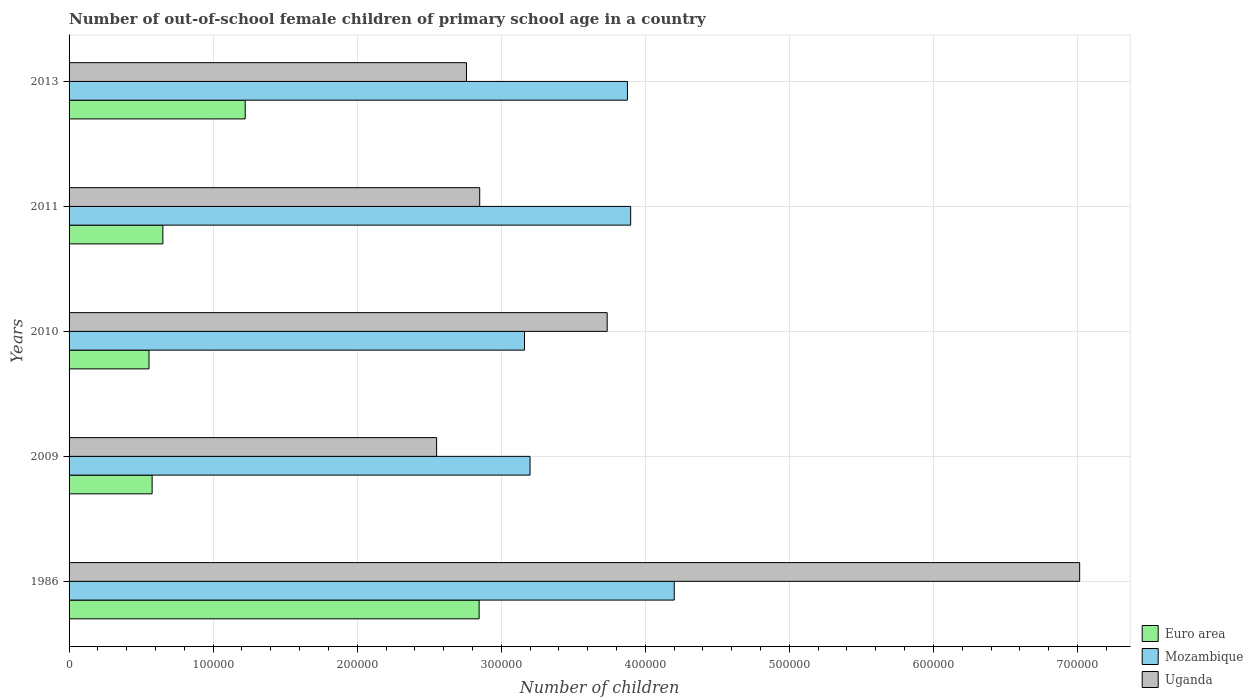How many different coloured bars are there?
Provide a succinct answer. 3. How many groups of bars are there?
Your response must be concise. 5. Are the number of bars per tick equal to the number of legend labels?
Keep it short and to the point. Yes. How many bars are there on the 5th tick from the top?
Your answer should be compact. 3. What is the label of the 3rd group of bars from the top?
Keep it short and to the point. 2010. What is the number of out-of-school female children in Uganda in 2013?
Keep it short and to the point. 2.76e+05. Across all years, what is the maximum number of out-of-school female children in Mozambique?
Your answer should be compact. 4.20e+05. Across all years, what is the minimum number of out-of-school female children in Euro area?
Your answer should be compact. 5.55e+04. In which year was the number of out-of-school female children in Uganda minimum?
Give a very brief answer. 2009. What is the total number of out-of-school female children in Euro area in the graph?
Give a very brief answer. 5.85e+05. What is the difference between the number of out-of-school female children in Mozambique in 2009 and that in 2011?
Provide a short and direct response. -6.98e+04. What is the difference between the number of out-of-school female children in Uganda in 2009 and the number of out-of-school female children in Euro area in 2011?
Give a very brief answer. 1.90e+05. What is the average number of out-of-school female children in Mozambique per year?
Your answer should be compact. 3.67e+05. In the year 2009, what is the difference between the number of out-of-school female children in Euro area and number of out-of-school female children in Mozambique?
Ensure brevity in your answer.  -2.62e+05. In how many years, is the number of out-of-school female children in Euro area greater than 340000 ?
Your response must be concise. 0. What is the ratio of the number of out-of-school female children in Euro area in 2009 to that in 2011?
Provide a succinct answer. 0.89. What is the difference between the highest and the second highest number of out-of-school female children in Mozambique?
Provide a succinct answer. 3.02e+04. What is the difference between the highest and the lowest number of out-of-school female children in Mozambique?
Your answer should be very brief. 1.04e+05. Is the sum of the number of out-of-school female children in Uganda in 1986 and 2013 greater than the maximum number of out-of-school female children in Mozambique across all years?
Provide a succinct answer. Yes. Are all the bars in the graph horizontal?
Provide a succinct answer. Yes. How many years are there in the graph?
Provide a short and direct response. 5. Are the values on the major ticks of X-axis written in scientific E-notation?
Your answer should be compact. No. Does the graph contain grids?
Provide a succinct answer. Yes. How many legend labels are there?
Your answer should be very brief. 3. What is the title of the graph?
Your answer should be very brief. Number of out-of-school female children of primary school age in a country. Does "Morocco" appear as one of the legend labels in the graph?
Ensure brevity in your answer.  No. What is the label or title of the X-axis?
Offer a very short reply. Number of children. What is the label or title of the Y-axis?
Make the answer very short. Years. What is the Number of children of Euro area in 1986?
Make the answer very short. 2.85e+05. What is the Number of children of Mozambique in 1986?
Your answer should be compact. 4.20e+05. What is the Number of children of Uganda in 1986?
Offer a terse response. 7.02e+05. What is the Number of children of Euro area in 2009?
Make the answer very short. 5.77e+04. What is the Number of children of Mozambique in 2009?
Ensure brevity in your answer.  3.20e+05. What is the Number of children of Uganda in 2009?
Provide a short and direct response. 2.55e+05. What is the Number of children in Euro area in 2010?
Provide a succinct answer. 5.55e+04. What is the Number of children of Mozambique in 2010?
Provide a short and direct response. 3.16e+05. What is the Number of children in Uganda in 2010?
Provide a succinct answer. 3.74e+05. What is the Number of children of Euro area in 2011?
Provide a short and direct response. 6.51e+04. What is the Number of children of Mozambique in 2011?
Offer a terse response. 3.90e+05. What is the Number of children in Uganda in 2011?
Keep it short and to the point. 2.85e+05. What is the Number of children of Euro area in 2013?
Your answer should be compact. 1.22e+05. What is the Number of children in Mozambique in 2013?
Provide a succinct answer. 3.88e+05. What is the Number of children in Uganda in 2013?
Ensure brevity in your answer.  2.76e+05. Across all years, what is the maximum Number of children of Euro area?
Keep it short and to the point. 2.85e+05. Across all years, what is the maximum Number of children of Mozambique?
Keep it short and to the point. 4.20e+05. Across all years, what is the maximum Number of children of Uganda?
Your answer should be very brief. 7.02e+05. Across all years, what is the minimum Number of children in Euro area?
Offer a terse response. 5.55e+04. Across all years, what is the minimum Number of children in Mozambique?
Ensure brevity in your answer.  3.16e+05. Across all years, what is the minimum Number of children in Uganda?
Give a very brief answer. 2.55e+05. What is the total Number of children of Euro area in the graph?
Your answer should be very brief. 5.85e+05. What is the total Number of children in Mozambique in the graph?
Your answer should be compact. 1.83e+06. What is the total Number of children of Uganda in the graph?
Keep it short and to the point. 1.89e+06. What is the difference between the Number of children in Euro area in 1986 and that in 2009?
Offer a very short reply. 2.27e+05. What is the difference between the Number of children of Mozambique in 1986 and that in 2009?
Provide a succinct answer. 1.00e+05. What is the difference between the Number of children of Uganda in 1986 and that in 2009?
Offer a very short reply. 4.46e+05. What is the difference between the Number of children of Euro area in 1986 and that in 2010?
Your answer should be compact. 2.29e+05. What is the difference between the Number of children in Mozambique in 1986 and that in 2010?
Provide a succinct answer. 1.04e+05. What is the difference between the Number of children in Uganda in 1986 and that in 2010?
Give a very brief answer. 3.28e+05. What is the difference between the Number of children in Euro area in 1986 and that in 2011?
Offer a terse response. 2.20e+05. What is the difference between the Number of children in Mozambique in 1986 and that in 2011?
Offer a very short reply. 3.02e+04. What is the difference between the Number of children of Uganda in 1986 and that in 2011?
Offer a very short reply. 4.16e+05. What is the difference between the Number of children in Euro area in 1986 and that in 2013?
Offer a terse response. 1.62e+05. What is the difference between the Number of children in Mozambique in 1986 and that in 2013?
Your answer should be compact. 3.25e+04. What is the difference between the Number of children of Uganda in 1986 and that in 2013?
Make the answer very short. 4.26e+05. What is the difference between the Number of children in Euro area in 2009 and that in 2010?
Offer a very short reply. 2158. What is the difference between the Number of children of Mozambique in 2009 and that in 2010?
Your answer should be compact. 3842. What is the difference between the Number of children in Uganda in 2009 and that in 2010?
Keep it short and to the point. -1.18e+05. What is the difference between the Number of children of Euro area in 2009 and that in 2011?
Your response must be concise. -7461. What is the difference between the Number of children of Mozambique in 2009 and that in 2011?
Your answer should be compact. -6.98e+04. What is the difference between the Number of children of Uganda in 2009 and that in 2011?
Your answer should be compact. -2.99e+04. What is the difference between the Number of children of Euro area in 2009 and that in 2013?
Ensure brevity in your answer.  -6.46e+04. What is the difference between the Number of children of Mozambique in 2009 and that in 2013?
Offer a very short reply. -6.76e+04. What is the difference between the Number of children in Uganda in 2009 and that in 2013?
Give a very brief answer. -2.07e+04. What is the difference between the Number of children in Euro area in 2010 and that in 2011?
Keep it short and to the point. -9619. What is the difference between the Number of children of Mozambique in 2010 and that in 2011?
Ensure brevity in your answer.  -7.37e+04. What is the difference between the Number of children of Uganda in 2010 and that in 2011?
Offer a terse response. 8.85e+04. What is the difference between the Number of children of Euro area in 2010 and that in 2013?
Provide a succinct answer. -6.68e+04. What is the difference between the Number of children of Mozambique in 2010 and that in 2013?
Ensure brevity in your answer.  -7.14e+04. What is the difference between the Number of children in Uganda in 2010 and that in 2013?
Provide a succinct answer. 9.77e+04. What is the difference between the Number of children in Euro area in 2011 and that in 2013?
Provide a short and direct response. -5.72e+04. What is the difference between the Number of children of Mozambique in 2011 and that in 2013?
Make the answer very short. 2252. What is the difference between the Number of children of Uganda in 2011 and that in 2013?
Your answer should be compact. 9186. What is the difference between the Number of children in Euro area in 1986 and the Number of children in Mozambique in 2009?
Provide a short and direct response. -3.53e+04. What is the difference between the Number of children in Euro area in 1986 and the Number of children in Uganda in 2009?
Your response must be concise. 2.95e+04. What is the difference between the Number of children of Mozambique in 1986 and the Number of children of Uganda in 2009?
Your response must be concise. 1.65e+05. What is the difference between the Number of children in Euro area in 1986 and the Number of children in Mozambique in 2010?
Make the answer very short. -3.15e+04. What is the difference between the Number of children of Euro area in 1986 and the Number of children of Uganda in 2010?
Offer a terse response. -8.89e+04. What is the difference between the Number of children in Mozambique in 1986 and the Number of children in Uganda in 2010?
Your response must be concise. 4.65e+04. What is the difference between the Number of children in Euro area in 1986 and the Number of children in Mozambique in 2011?
Offer a terse response. -1.05e+05. What is the difference between the Number of children in Euro area in 1986 and the Number of children in Uganda in 2011?
Provide a short and direct response. -399. What is the difference between the Number of children in Mozambique in 1986 and the Number of children in Uganda in 2011?
Offer a terse response. 1.35e+05. What is the difference between the Number of children of Euro area in 1986 and the Number of children of Mozambique in 2013?
Make the answer very short. -1.03e+05. What is the difference between the Number of children of Euro area in 1986 and the Number of children of Uganda in 2013?
Your response must be concise. 8787. What is the difference between the Number of children in Mozambique in 1986 and the Number of children in Uganda in 2013?
Provide a succinct answer. 1.44e+05. What is the difference between the Number of children of Euro area in 2009 and the Number of children of Mozambique in 2010?
Make the answer very short. -2.59e+05. What is the difference between the Number of children in Euro area in 2009 and the Number of children in Uganda in 2010?
Your answer should be very brief. -3.16e+05. What is the difference between the Number of children of Mozambique in 2009 and the Number of children of Uganda in 2010?
Provide a short and direct response. -5.36e+04. What is the difference between the Number of children in Euro area in 2009 and the Number of children in Mozambique in 2011?
Your answer should be compact. -3.32e+05. What is the difference between the Number of children of Euro area in 2009 and the Number of children of Uganda in 2011?
Ensure brevity in your answer.  -2.27e+05. What is the difference between the Number of children of Mozambique in 2009 and the Number of children of Uganda in 2011?
Your answer should be compact. 3.49e+04. What is the difference between the Number of children of Euro area in 2009 and the Number of children of Mozambique in 2013?
Offer a very short reply. -3.30e+05. What is the difference between the Number of children in Euro area in 2009 and the Number of children in Uganda in 2013?
Make the answer very short. -2.18e+05. What is the difference between the Number of children of Mozambique in 2009 and the Number of children of Uganda in 2013?
Your answer should be very brief. 4.41e+04. What is the difference between the Number of children of Euro area in 2010 and the Number of children of Mozambique in 2011?
Offer a terse response. -3.34e+05. What is the difference between the Number of children of Euro area in 2010 and the Number of children of Uganda in 2011?
Make the answer very short. -2.30e+05. What is the difference between the Number of children of Mozambique in 2010 and the Number of children of Uganda in 2011?
Your answer should be compact. 3.11e+04. What is the difference between the Number of children in Euro area in 2010 and the Number of children in Mozambique in 2013?
Offer a very short reply. -3.32e+05. What is the difference between the Number of children of Euro area in 2010 and the Number of children of Uganda in 2013?
Provide a short and direct response. -2.20e+05. What is the difference between the Number of children in Mozambique in 2010 and the Number of children in Uganda in 2013?
Provide a short and direct response. 4.03e+04. What is the difference between the Number of children in Euro area in 2011 and the Number of children in Mozambique in 2013?
Ensure brevity in your answer.  -3.22e+05. What is the difference between the Number of children of Euro area in 2011 and the Number of children of Uganda in 2013?
Your answer should be compact. -2.11e+05. What is the difference between the Number of children of Mozambique in 2011 and the Number of children of Uganda in 2013?
Offer a terse response. 1.14e+05. What is the average Number of children of Euro area per year?
Ensure brevity in your answer.  1.17e+05. What is the average Number of children of Mozambique per year?
Provide a succinct answer. 3.67e+05. What is the average Number of children of Uganda per year?
Provide a succinct answer. 3.78e+05. In the year 1986, what is the difference between the Number of children of Euro area and Number of children of Mozambique?
Ensure brevity in your answer.  -1.35e+05. In the year 1986, what is the difference between the Number of children of Euro area and Number of children of Uganda?
Offer a terse response. -4.17e+05. In the year 1986, what is the difference between the Number of children in Mozambique and Number of children in Uganda?
Provide a short and direct response. -2.81e+05. In the year 2009, what is the difference between the Number of children of Euro area and Number of children of Mozambique?
Ensure brevity in your answer.  -2.62e+05. In the year 2009, what is the difference between the Number of children of Euro area and Number of children of Uganda?
Offer a terse response. -1.97e+05. In the year 2009, what is the difference between the Number of children of Mozambique and Number of children of Uganda?
Give a very brief answer. 6.49e+04. In the year 2010, what is the difference between the Number of children in Euro area and Number of children in Mozambique?
Provide a short and direct response. -2.61e+05. In the year 2010, what is the difference between the Number of children of Euro area and Number of children of Uganda?
Your response must be concise. -3.18e+05. In the year 2010, what is the difference between the Number of children of Mozambique and Number of children of Uganda?
Offer a very short reply. -5.74e+04. In the year 2011, what is the difference between the Number of children in Euro area and Number of children in Mozambique?
Ensure brevity in your answer.  -3.25e+05. In the year 2011, what is the difference between the Number of children in Euro area and Number of children in Uganda?
Keep it short and to the point. -2.20e+05. In the year 2011, what is the difference between the Number of children in Mozambique and Number of children in Uganda?
Your answer should be compact. 1.05e+05. In the year 2013, what is the difference between the Number of children of Euro area and Number of children of Mozambique?
Your answer should be very brief. -2.65e+05. In the year 2013, what is the difference between the Number of children of Euro area and Number of children of Uganda?
Offer a terse response. -1.54e+05. In the year 2013, what is the difference between the Number of children of Mozambique and Number of children of Uganda?
Provide a short and direct response. 1.12e+05. What is the ratio of the Number of children in Euro area in 1986 to that in 2009?
Make the answer very short. 4.94. What is the ratio of the Number of children of Mozambique in 1986 to that in 2009?
Offer a very short reply. 1.31. What is the ratio of the Number of children in Uganda in 1986 to that in 2009?
Provide a short and direct response. 2.75. What is the ratio of the Number of children of Euro area in 1986 to that in 2010?
Offer a terse response. 5.13. What is the ratio of the Number of children of Mozambique in 1986 to that in 2010?
Offer a terse response. 1.33. What is the ratio of the Number of children of Uganda in 1986 to that in 2010?
Make the answer very short. 1.88. What is the ratio of the Number of children in Euro area in 1986 to that in 2011?
Offer a very short reply. 4.37. What is the ratio of the Number of children of Mozambique in 1986 to that in 2011?
Give a very brief answer. 1.08. What is the ratio of the Number of children in Uganda in 1986 to that in 2011?
Your response must be concise. 2.46. What is the ratio of the Number of children in Euro area in 1986 to that in 2013?
Provide a succinct answer. 2.33. What is the ratio of the Number of children of Mozambique in 1986 to that in 2013?
Provide a short and direct response. 1.08. What is the ratio of the Number of children in Uganda in 1986 to that in 2013?
Your answer should be very brief. 2.54. What is the ratio of the Number of children of Euro area in 2009 to that in 2010?
Give a very brief answer. 1.04. What is the ratio of the Number of children of Mozambique in 2009 to that in 2010?
Keep it short and to the point. 1.01. What is the ratio of the Number of children in Uganda in 2009 to that in 2010?
Offer a terse response. 0.68. What is the ratio of the Number of children in Euro area in 2009 to that in 2011?
Provide a succinct answer. 0.89. What is the ratio of the Number of children in Mozambique in 2009 to that in 2011?
Ensure brevity in your answer.  0.82. What is the ratio of the Number of children of Uganda in 2009 to that in 2011?
Give a very brief answer. 0.9. What is the ratio of the Number of children in Euro area in 2009 to that in 2013?
Your response must be concise. 0.47. What is the ratio of the Number of children in Mozambique in 2009 to that in 2013?
Give a very brief answer. 0.83. What is the ratio of the Number of children in Uganda in 2009 to that in 2013?
Ensure brevity in your answer.  0.92. What is the ratio of the Number of children of Euro area in 2010 to that in 2011?
Make the answer very short. 0.85. What is the ratio of the Number of children of Mozambique in 2010 to that in 2011?
Give a very brief answer. 0.81. What is the ratio of the Number of children in Uganda in 2010 to that in 2011?
Your response must be concise. 1.31. What is the ratio of the Number of children in Euro area in 2010 to that in 2013?
Provide a succinct answer. 0.45. What is the ratio of the Number of children of Mozambique in 2010 to that in 2013?
Offer a very short reply. 0.82. What is the ratio of the Number of children in Uganda in 2010 to that in 2013?
Ensure brevity in your answer.  1.35. What is the ratio of the Number of children in Euro area in 2011 to that in 2013?
Give a very brief answer. 0.53. What is the difference between the highest and the second highest Number of children in Euro area?
Offer a very short reply. 1.62e+05. What is the difference between the highest and the second highest Number of children of Mozambique?
Your response must be concise. 3.02e+04. What is the difference between the highest and the second highest Number of children in Uganda?
Offer a terse response. 3.28e+05. What is the difference between the highest and the lowest Number of children of Euro area?
Your answer should be compact. 2.29e+05. What is the difference between the highest and the lowest Number of children in Mozambique?
Make the answer very short. 1.04e+05. What is the difference between the highest and the lowest Number of children in Uganda?
Your response must be concise. 4.46e+05. 